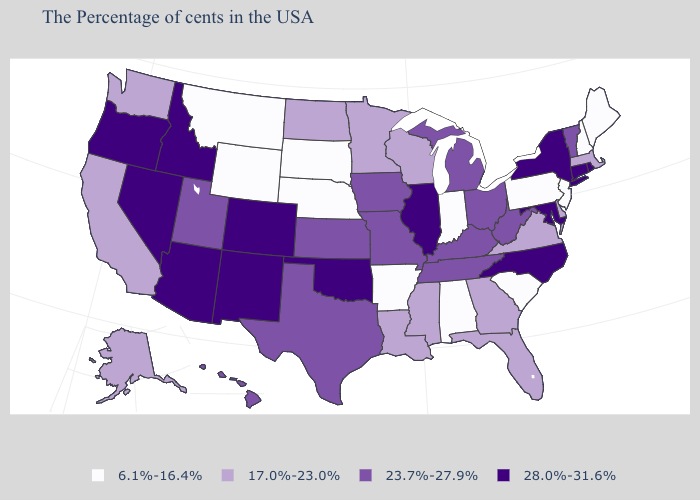What is the highest value in the USA?
Keep it brief. 28.0%-31.6%. What is the value of Michigan?
Quick response, please. 23.7%-27.9%. Among the states that border Minnesota , does South Dakota have the highest value?
Write a very short answer. No. What is the value of Florida?
Write a very short answer. 17.0%-23.0%. Does Arizona have the highest value in the USA?
Keep it brief. Yes. Name the states that have a value in the range 17.0%-23.0%?
Write a very short answer. Massachusetts, Delaware, Virginia, Florida, Georgia, Wisconsin, Mississippi, Louisiana, Minnesota, North Dakota, California, Washington, Alaska. Does New Mexico have the same value as Maryland?
Write a very short answer. Yes. Name the states that have a value in the range 6.1%-16.4%?
Short answer required. Maine, New Hampshire, New Jersey, Pennsylvania, South Carolina, Indiana, Alabama, Arkansas, Nebraska, South Dakota, Wyoming, Montana. Which states hav the highest value in the West?
Short answer required. Colorado, New Mexico, Arizona, Idaho, Nevada, Oregon. Is the legend a continuous bar?
Quick response, please. No. What is the value of Maine?
Write a very short answer. 6.1%-16.4%. What is the value of Utah?
Short answer required. 23.7%-27.9%. Which states hav the highest value in the West?
Keep it brief. Colorado, New Mexico, Arizona, Idaho, Nevada, Oregon. What is the value of Oregon?
Keep it brief. 28.0%-31.6%. Does Arizona have the highest value in the West?
Answer briefly. Yes. 